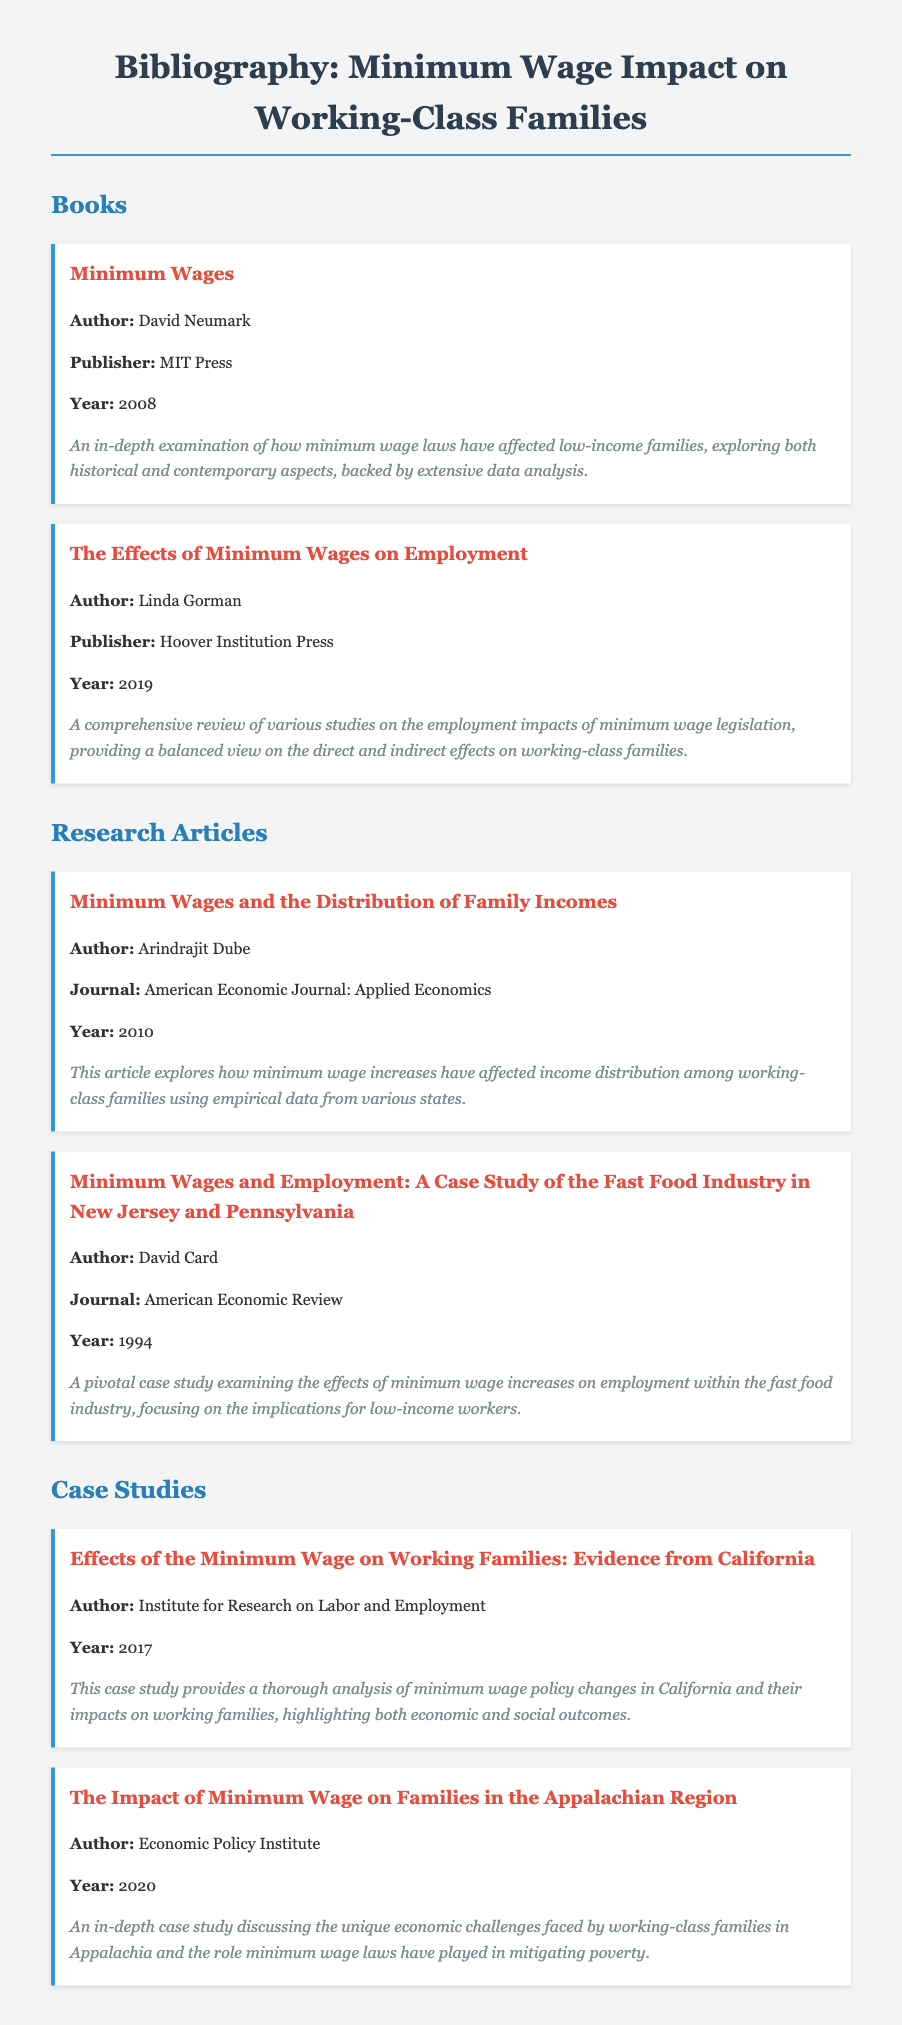What is the title of the book by David Neumark? The title is found in the "Books" section of the bibliography, where it lists books along with their authors and details.
Answer: Minimum Wages Who published "The Effects of Minimum Wages on Employment"? This information can be retrieved from the entry titled “The Effects of Minimum Wages on Employment” in the "Books" section.
Answer: Hoover Institution Press What year was the article by Arindrajit Dube published? The publication year is specified in the citation for the article under "Research Articles."
Answer: 2010 Which case study discusses the impact of minimum wage on families in Appalachia? The title of the case study is provided in the "Case Studies" section of the document.
Answer: The Impact of Minimum Wage on Families in the Appalachian Region Who is the author of the pivotal case study on the fast food industry? This detail is found in the entry for that specific article within the "Research Articles" section.
Answer: David Card What is a primary focus of the case study by the Economic Policy Institute? The description of the case study outlines its specific focus and findings related to working-class families.
Answer: Economic challenges in Appalachia What is the central theme of the book by Linda Gorman? The description offers insight into the primary concerns addressed in the book related to employment impacts.
Answer: Employment impacts of minimum wage legislation What institution authored the case study on minimum wage effects in California? This detail is clearly identified in the "Case Studies" section under the corresponding entry.
Answer: Institute for Research on Labor and Employment 